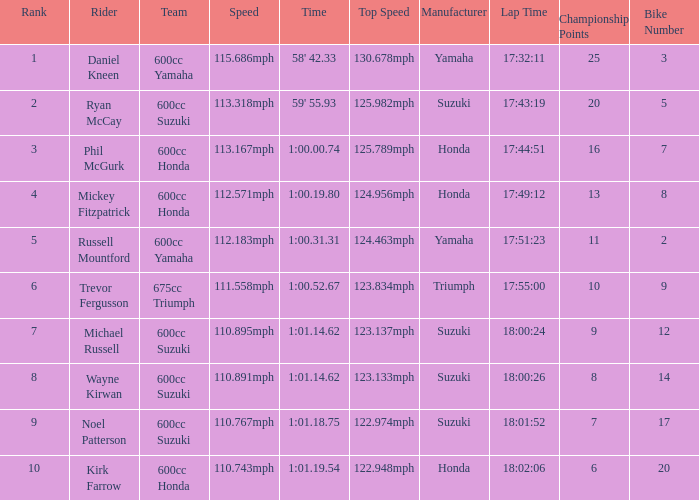What time has phil mcgurk as the rider? 1:00.00.74. 